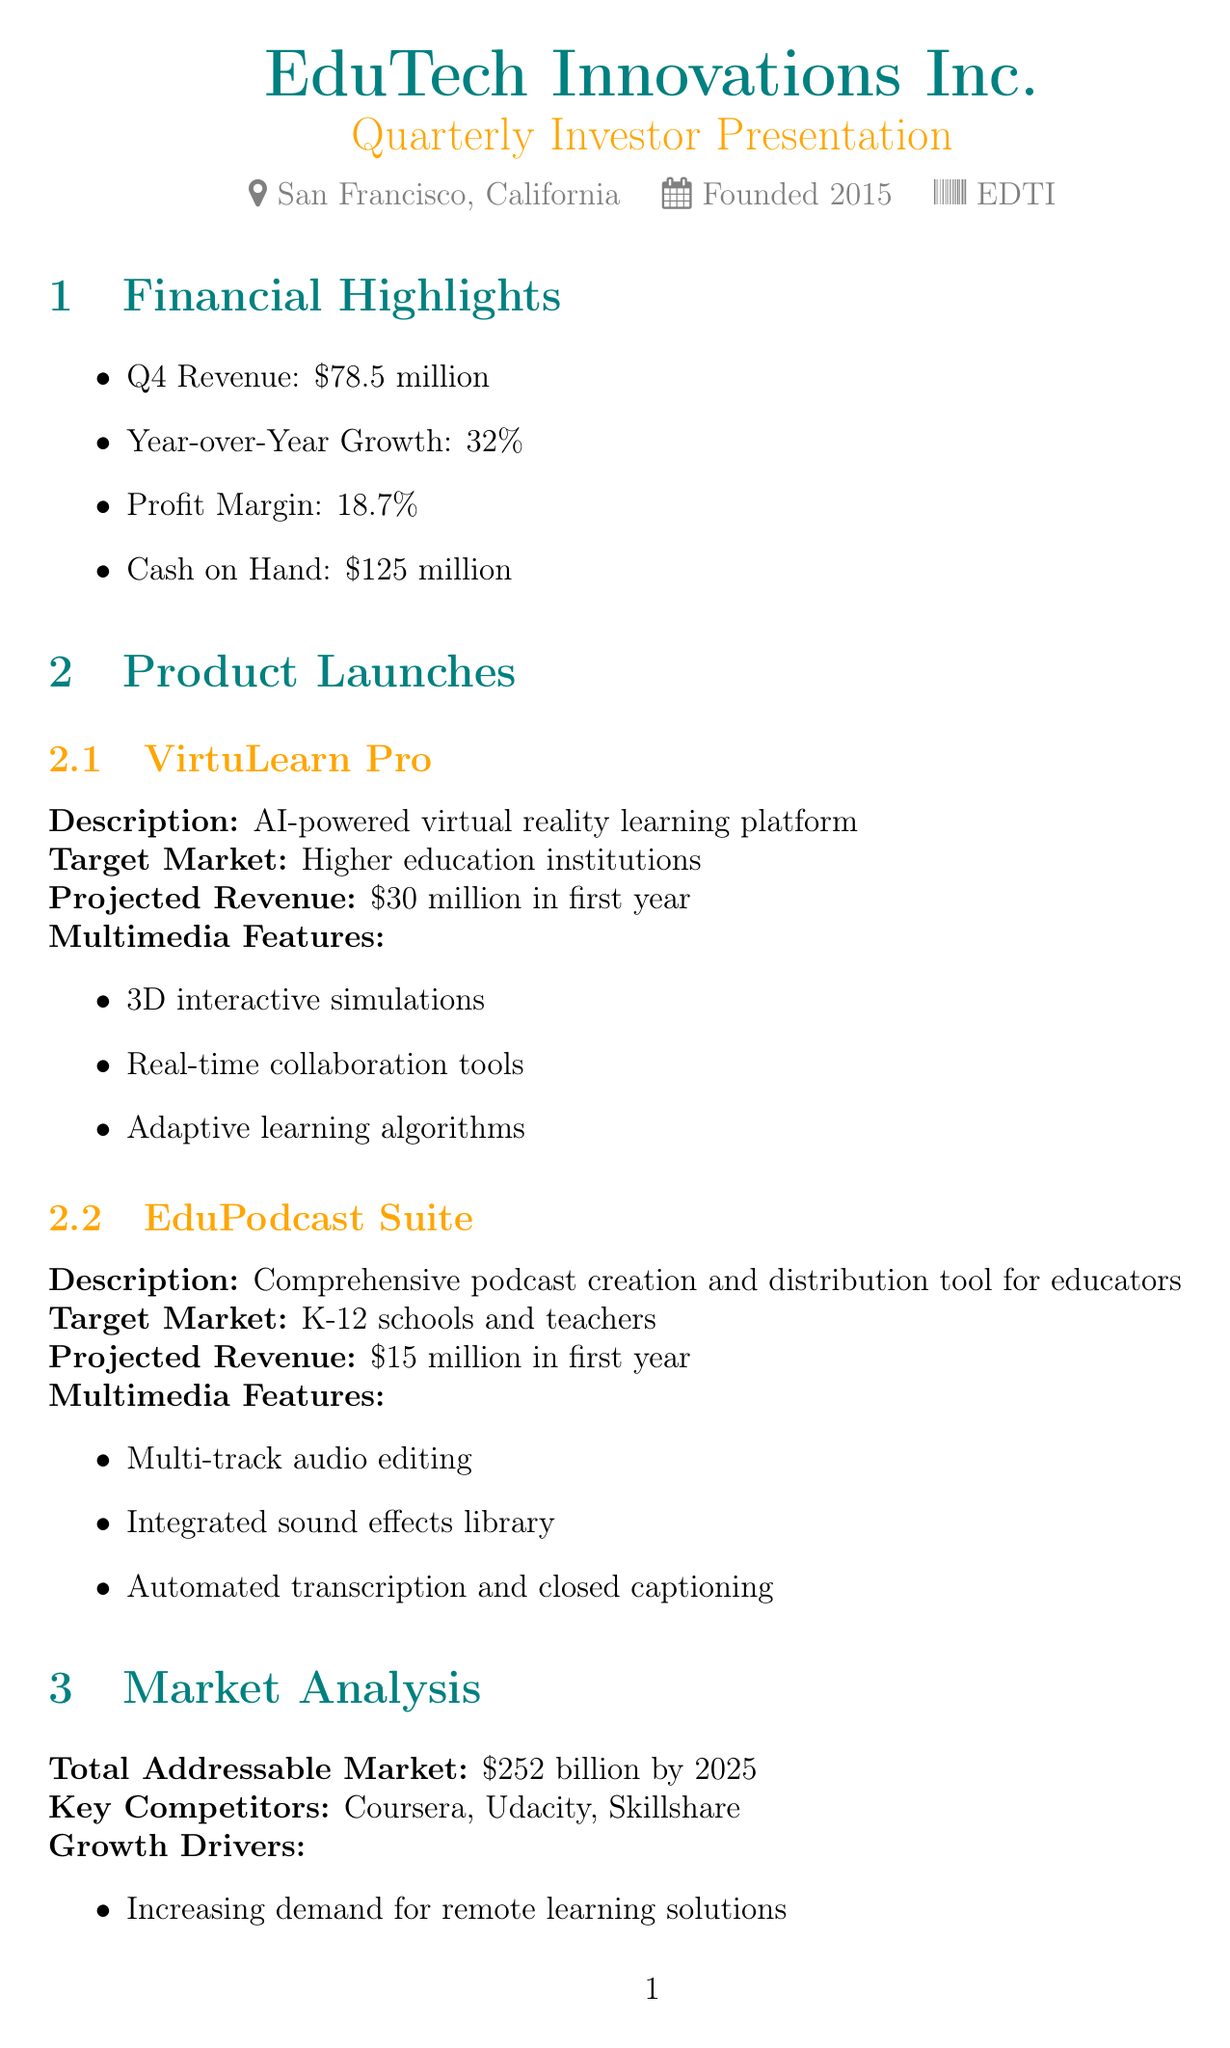What is the company's name? The company's name is stated in the document as part of the heading.
Answer: EduTech Innovations Inc What is the projected revenue for VirtuLearn Pro in the first year? The projected revenue is specified for each product launch in the document.
Answer: $30 million in first year Who is the CEO of EduTech Innovations Inc.? The CEO's name is mentioned in the company information section of the document.
Answer: Alexandra Chen What is the profit margin reported in the financial highlights? The profit margin is highlighted under the financial section of the document.
Answer: 18.7% What are the key competitors listed in the market analysis? The key competitors are outlined in the market analysis segment of the document.
Answer: Coursera, Udacity, Skillshare What multimedia feature is included in the EduPodcast Suite? The document lists multimedia features for each product launch.
Answer: Multi-track audio editing How much cash on hand does the company have? The amount of cash on hand is included in the financial highlights section.
Answer: $125 million What future product is expected to launch in Q4 2024? The expected launch date for future products is detailed in the future outlook.
Answer: EduMetaverse How much has the brand reach expanded due to multimedia tools? The impact on business from multimedia success is quantified in the document.
Answer: 300% What is the total addressable market by 2025? The total addressable market is specified in the market analysis section.
Answer: $252 billion by 2025 